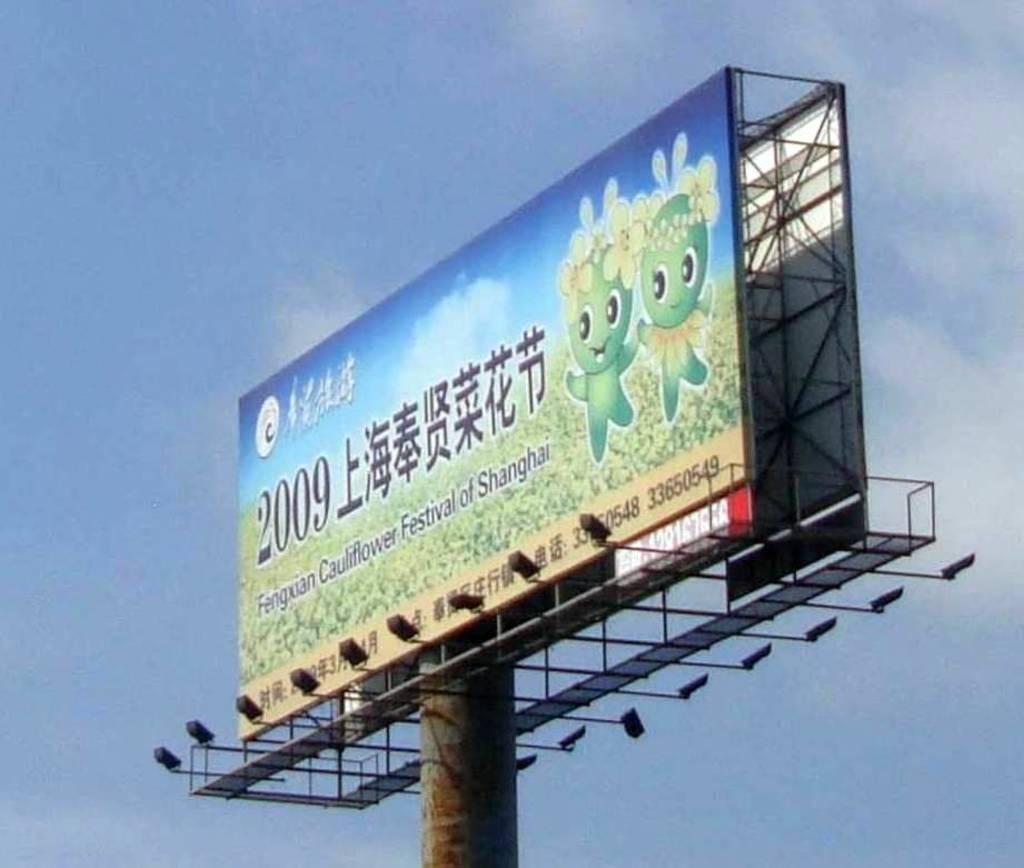What year is shown in the billboard?
Give a very brief answer. 2009. 